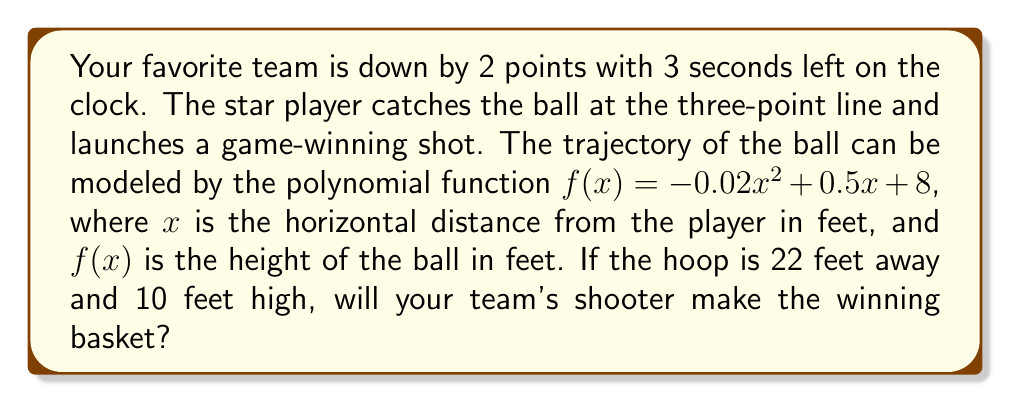Could you help me with this problem? Let's approach this step-by-step:

1) We need to determine if the ball will pass through the hoop, which is 22 feet away and 10 feet high.

2) To find the height of the ball at 22 feet, we need to calculate $f(22)$:

   $f(22) = -0.02(22)^2 + 0.5(22) + 8$
   
   $= -0.02(484) + 11 + 8$
   
   $= -9.68 + 19$
   
   $= 9.32$ feet

3) The ball will be approximately 9.32 feet high when it reaches the hoop, which is 10 feet high.

4) However, we need to consider that the ball doesn't need to be exactly 10 feet high to go through the hoop. A regulation basketball is about 9.5 inches in diameter, and the hoop has an 18-inch diameter.

5) This means the ball can go through the hoop if its center is between 9.21 feet (10 - 9.5/12) and 10.79 feet (10 + 9.5/12) high.

6) Since 9.32 feet falls within this range, the ball will go through the hoop.

As a longtime supporter with unwavering faith in the team, your belief in the star player's ability to make the winning shot is justified by the mathematics!
Answer: Yes, the star player will make the game-winning shot. The ball will be approximately 9.32 feet high when it reaches the hoop, which is within the range needed to score. 